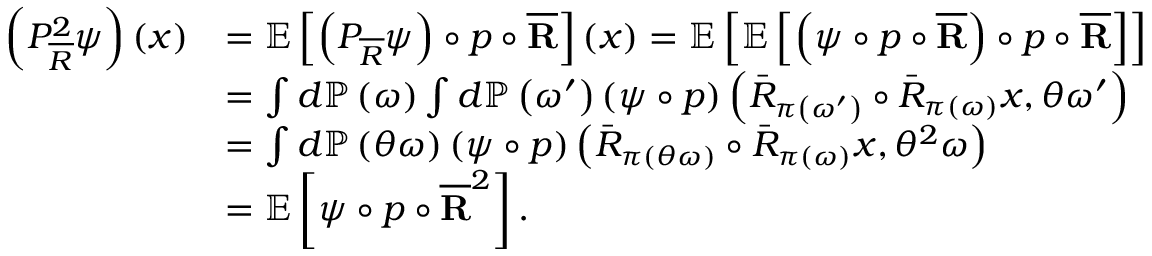Convert formula to latex. <formula><loc_0><loc_0><loc_500><loc_500>\begin{array} { r l } { \left ( P _ { \overline { R } } ^ { 2 } \psi \right ) \left ( x \right ) } & { = \mathbb { E } \left [ \left ( P _ { \overline { R } } \psi \right ) \circ p \circ \overline { R } \right ] \left ( x \right ) = \mathbb { E } \left [ \mathbb { E } \left [ \left ( \psi \circ p \circ \overline { R } \right ) \circ p \circ \overline { R } \right ] \right ] } \\ & { = \int d \mathbb { P } \left ( \omega \right ) \int d \mathbb { P } \left ( \omega ^ { \prime } \right ) \left ( \psi \circ p \right ) \left ( \bar { R } _ { \pi \left ( \omega ^ { \prime } \right ) } \circ \bar { R } _ { \pi \left ( \omega \right ) } x , \theta \omega ^ { \prime } \right ) } \\ & { = \int d \mathbb { P } \left ( \theta \omega \right ) \left ( \psi \circ p \right ) \left ( \bar { R } _ { \pi \left ( \theta \omega \right ) } \circ \bar { R } _ { \pi \left ( \omega \right ) } x , \theta ^ { 2 } \omega \right ) } \\ & { = \mathbb { E } \left [ \psi \circ p \circ \overline { R } ^ { 2 } \right ] . } \end{array}</formula> 